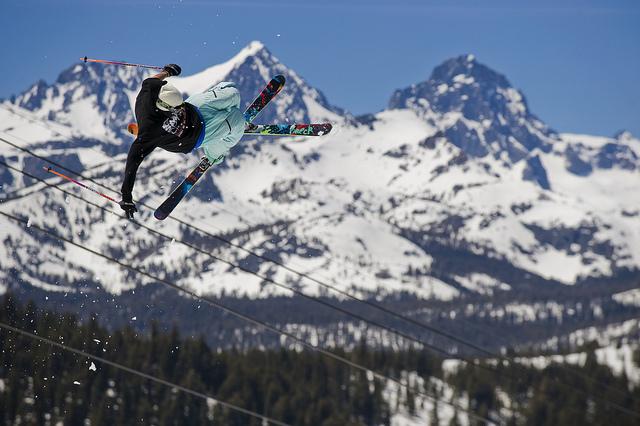What sport is the man going to participate in?
Write a very short answer. Skiing. What is covering the mountains?
Give a very brief answer. Snow. Is that the Mormon church in the background?
Be succinct. No. Is this picture taken in the midwest?
Quick response, please. No. How many mountains are in this scene?
Give a very brief answer. 3. Are there clouds in the sky?
Give a very brief answer. No. Where is this activity taking place?
Give a very brief answer. Mountains. Why is the person suspended in mid-air?
Answer briefly. Skiing. Is the person falling or rising?
Short answer required. Falling. Are most of the people entering or leaving?
Concise answer only. Entering. What is blocking the picture?
Quick response, please. Skier. What activity is the man in the red shirt engaging in?
Be succinct. Skiing. 